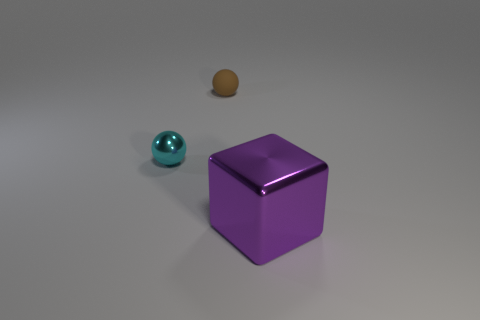Are there any other things that have the same size as the purple shiny block?
Make the answer very short. No. Is the number of cyan metallic objects that are behind the brown ball greater than the number of metallic things that are behind the big metal object?
Keep it short and to the point. No. What color is the metallic thing that is on the left side of the metal object that is to the right of the tiny thing that is in front of the matte thing?
Ensure brevity in your answer.  Cyan. Does the shiny object that is behind the large thing have the same color as the rubber sphere?
Offer a very short reply. No. What number of other objects are the same color as the rubber thing?
Your response must be concise. 0. How many objects are either small cyan things or big yellow shiny spheres?
Make the answer very short. 1. What number of objects are brown matte spheres or objects in front of the small brown rubber thing?
Make the answer very short. 3. Are the purple thing and the small brown ball made of the same material?
Your answer should be compact. No. What number of other objects are there of the same material as the large cube?
Keep it short and to the point. 1. Are there more big cyan metal objects than balls?
Your answer should be very brief. No. 